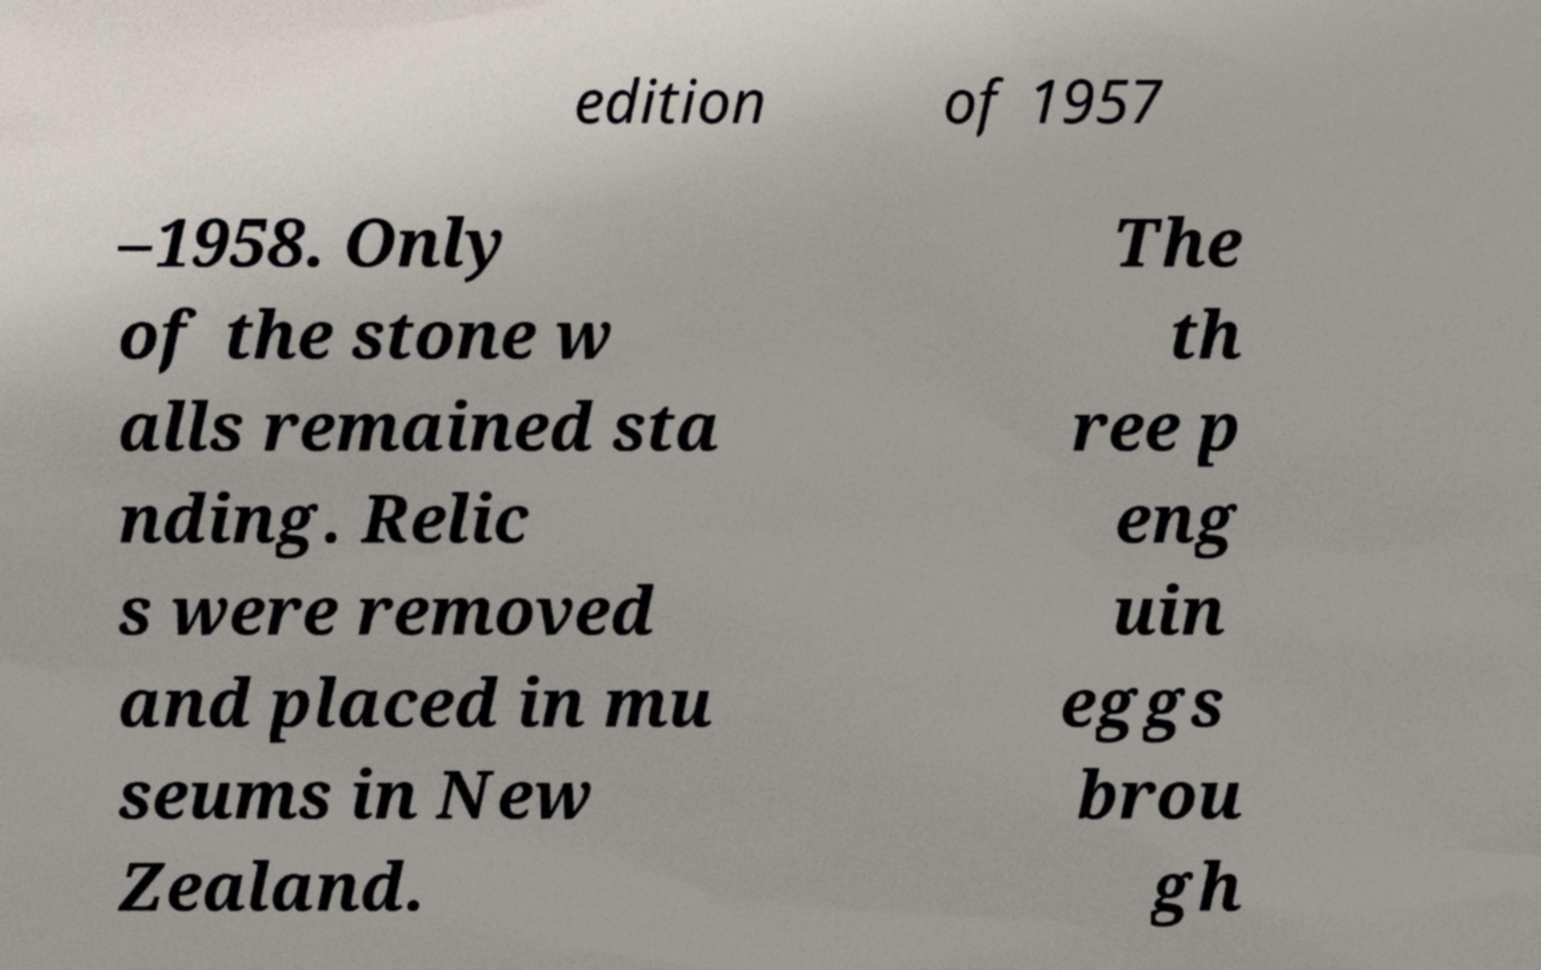Please read and relay the text visible in this image. What does it say? edition of 1957 –1958. Only of the stone w alls remained sta nding. Relic s were removed and placed in mu seums in New Zealand. The th ree p eng uin eggs brou gh 